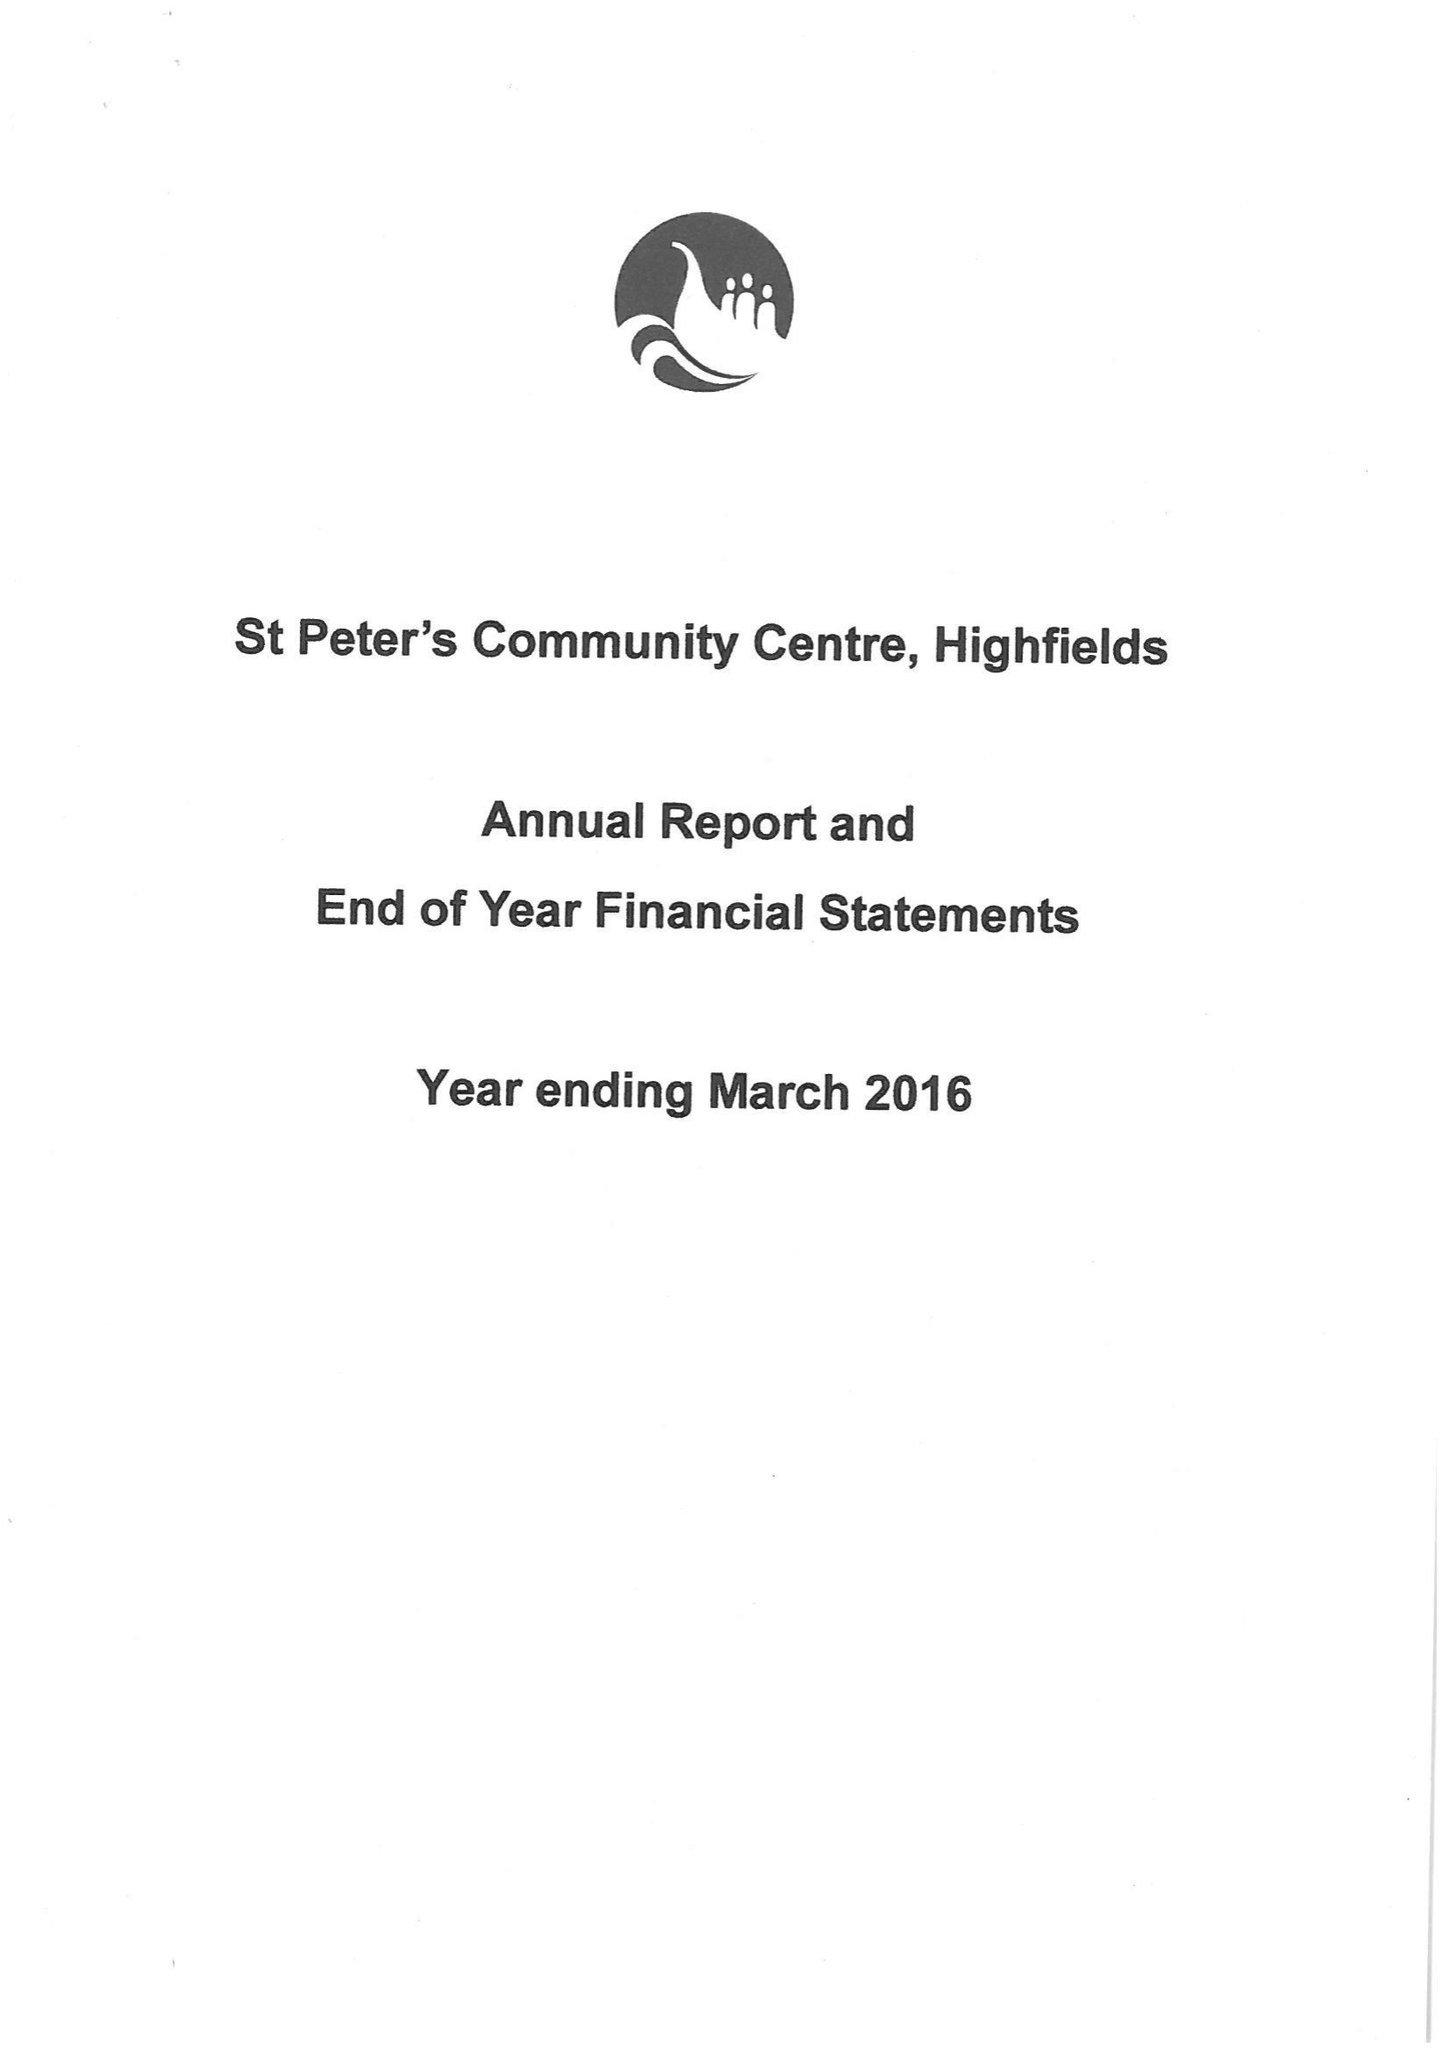What is the value for the income_annually_in_british_pounds?
Answer the question using a single word or phrase. 50764.76 